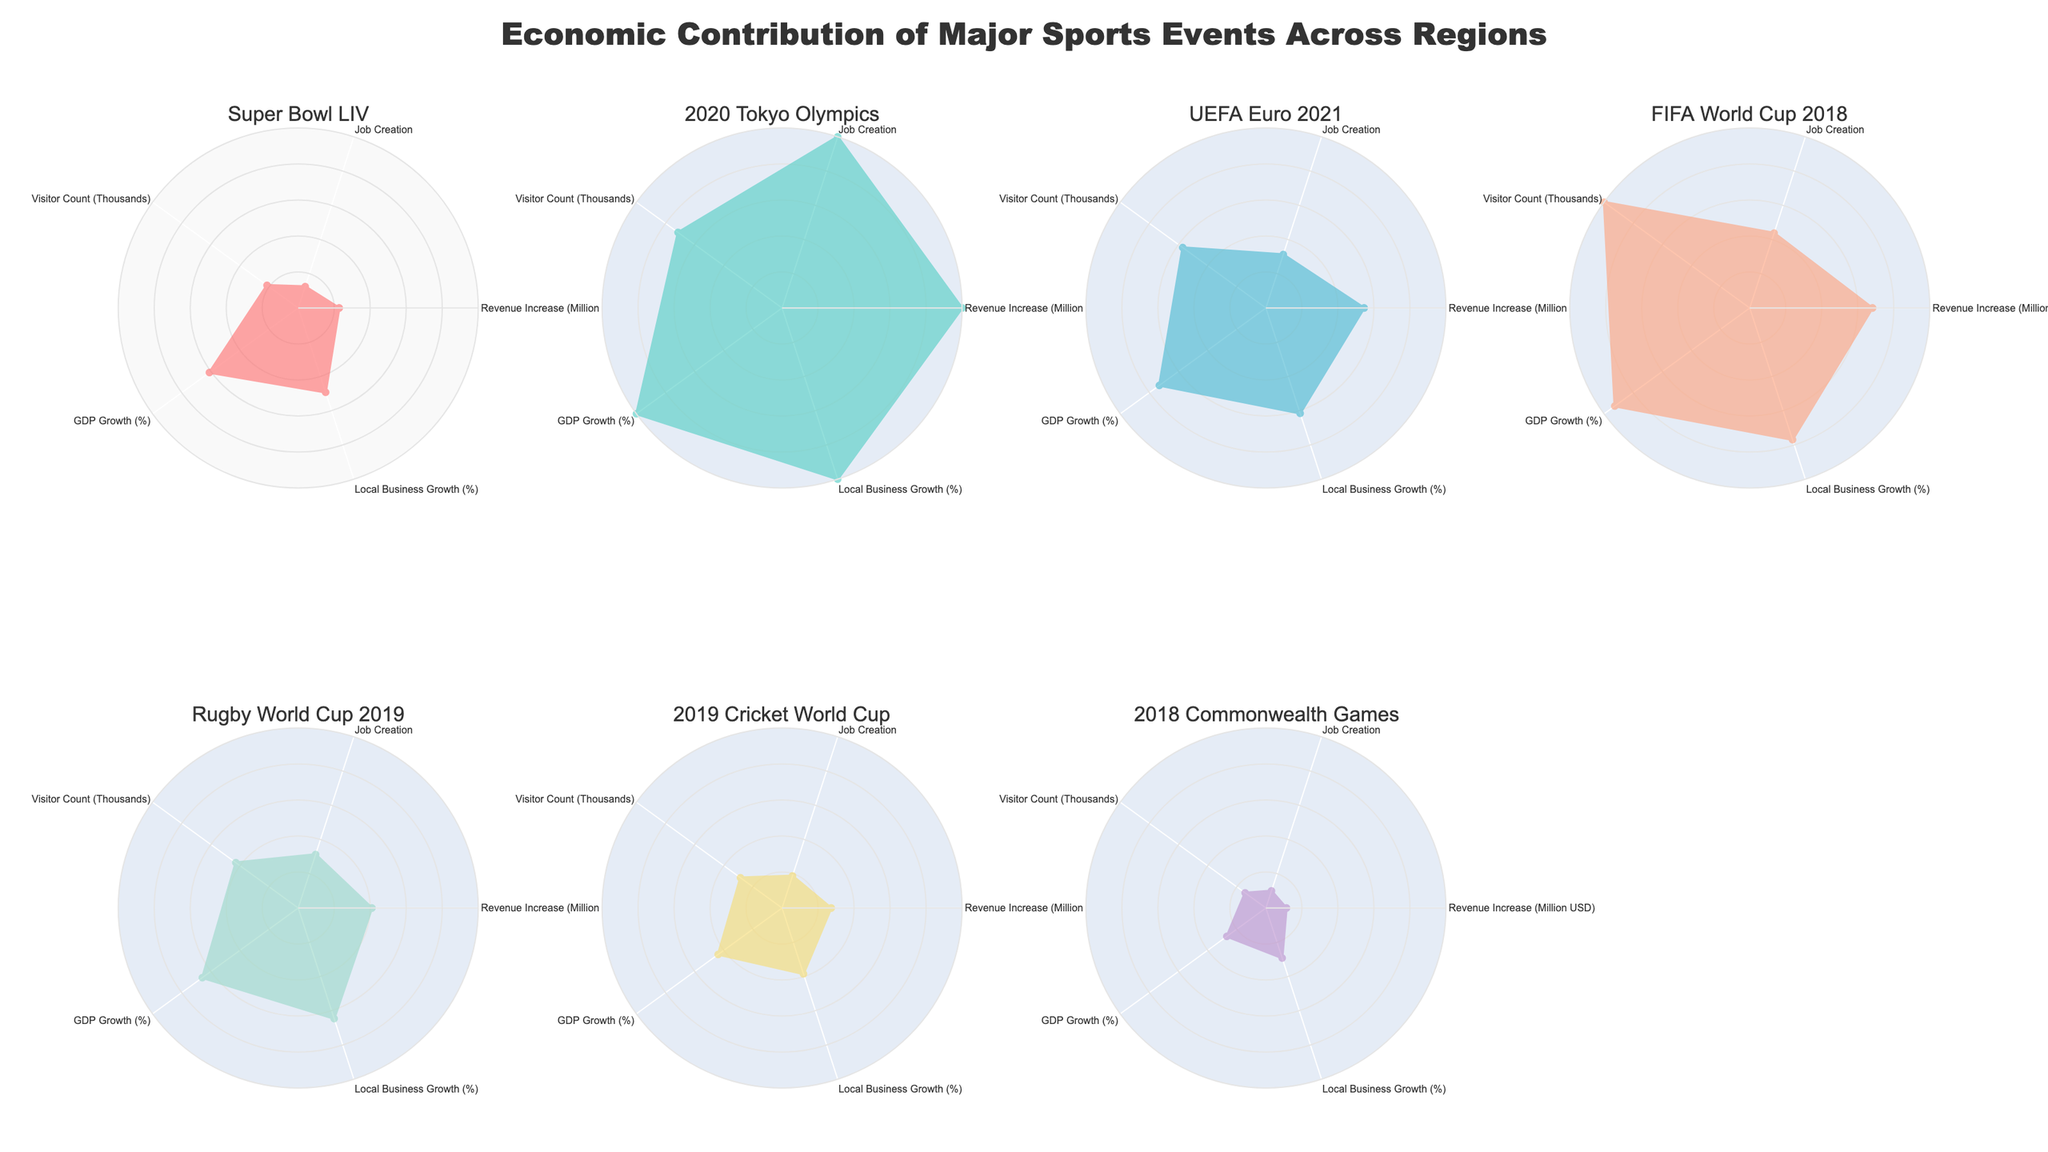What is the title of the figure? The title is located at the top center of the figure, displayed prominently in a larger font. It summarizes the content of the plot.
Answer: Economic Contribution of Major Sports Events Across Regions Which event shows the highest revenue increase? By looking at the radar chart's axes labeled 'Revenue Increase (Million USD)', the event with the furthest point from the center represents the highest value.
Answer: 2020 Tokyo Olympics Which event has the highest number of job creations? Examine the 'Job Creation' axis of each subplot. The event reaching the furthest point from the center on this axis indicates the highest number of job creations.
Answer: 2020 Tokyo Olympics Which two events show the most similar GDP growth? To compare, look at the 'GDP Growth (%)' axis across all events. Identify the events where the points fall closest to each other on this axis.
Answer: Super Bowl LIV and Rugby World Cup 2019 What is the correlation between local business growth and visitor count in Tokyo? For the 2020 Tokyo Olympics subplot, observe the positions on the 'Local Business Growth (%)' and 'Visitor Count (Thousands)' axes. Both should show whether they increase or decrease together.
Answer: Both are high How does the Revenue Increase of the UEFA Euro 2021 compare to the Rugby World Cup 2019? Examine the 'Revenue Increase (Million USD)' axis for both events. Compare the distances from the center to determine which event has a higher value.
Answer: UEFA Euro 2021 is higher Which event shows the lowest impact in terms of visitor count? Look at the 'Visitor Count (Thousands)' axis for all events and find the subplot with the point closest to the center.
Answer: 2018 Commonwealth Games Is there an event where the values for GDP Growth and Local Business Growth are almost the same? Check each subplot to compare the points on 'GDP Growth (%)' and 'Local Business Growth (%)'. Identify if any subplots have nearly equal values for these metrics.
Answer: 2019 Cricket World Cup Which event contributes most evenly across all categories (Revenue Increase, Job Creation, Visitor Count, GDP Growth, Local Business Growth)? An evenly contributing event will have points roughly equidistant from the center across all categories. Look for the most balanced radar shape.
Answer: Rugby World Cup 2019 